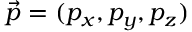<formula> <loc_0><loc_0><loc_500><loc_500>\vec { p } = ( p _ { x } , p _ { y } , p _ { z } )</formula> 